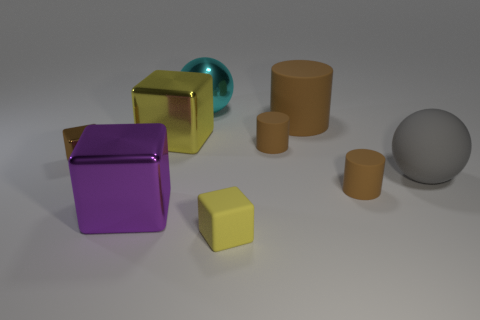Add 1 large cubes. How many objects exist? 10 Subtract all cubes. How many objects are left? 5 Subtract 0 gray cylinders. How many objects are left? 9 Subtract all small brown shiny cubes. Subtract all large brown metallic cubes. How many objects are left? 8 Add 2 big purple things. How many big purple things are left? 3 Add 4 red rubber things. How many red rubber things exist? 4 